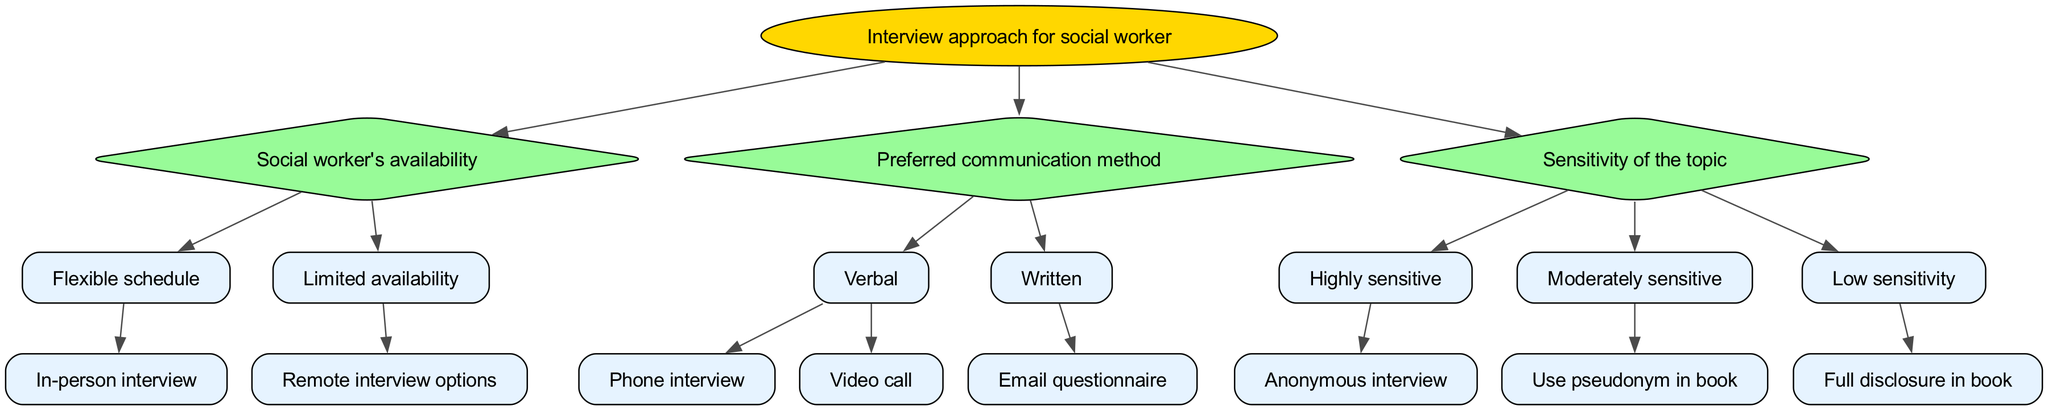What is the root of the decision tree? The root of the decision tree is the main topic that guides the flow of decisions. In this case, it's "Interview approach for social worker."
Answer: Interview approach for social worker How many main categories are there in the decision tree? The decision tree has three main categories: social worker's availability, preferred communication method, and sensitivity of the topic. Hence, the total is three.
Answer: 3 What type of interview is suggested for a social worker with a flexible schedule? The diagram indicates that for a social worker with a flexible schedule, the best approach is to conduct an in-person interview.
Answer: In-person interview What communication method is recommended for a social worker who prefers written communication? According to the diagram, if a social worker prefers written communication, the recommended method is to use an email questionnaire.
Answer: Email questionnaire What option is available if the topic of discussion is highly sensitive? The diagram shows that for highly sensitive topics, the recommended option is to conduct an anonymous interview.
Answer: Anonymous interview If a social worker's availability is limited, what type of interview should be considered? The decision tree suggests that if a social worker has limited availability, one should consider remote interview options.
Answer: Remote interview options Which option involves using a pseudonym in the book? The diagram indicates that using a pseudonym in the book is appropriate for moderately sensitive topics.
Answer: Use pseudonym in book What is the recommended course of action for a low sensitivity topic in the interview? According to the decision tree, for a low sensitivity topic, the recommended course of action is full disclosure in the book.
Answer: Full disclosure in book For a social worker with a verbal communication preference, what are the two interview methods available? The decision tree shows that for a verbal communication preference, the available methods are phone interview and video call.
Answer: Phone interview and video call 